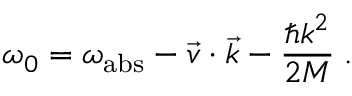<formula> <loc_0><loc_0><loc_500><loc_500>\omega _ { 0 } = \omega _ { a b s } - \vec { v } \cdot \vec { k } - \frac { \hbar { k } ^ { 2 } } { 2 M } \, .</formula> 